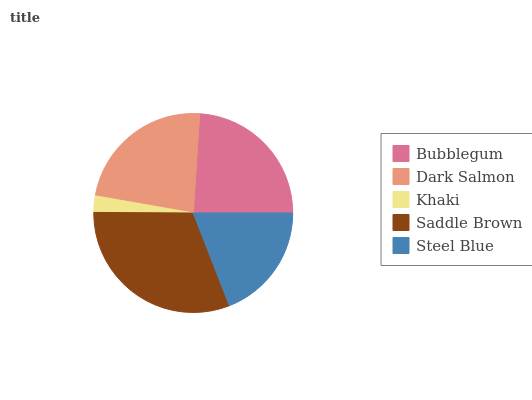Is Khaki the minimum?
Answer yes or no. Yes. Is Saddle Brown the maximum?
Answer yes or no. Yes. Is Dark Salmon the minimum?
Answer yes or no. No. Is Dark Salmon the maximum?
Answer yes or no. No. Is Bubblegum greater than Dark Salmon?
Answer yes or no. Yes. Is Dark Salmon less than Bubblegum?
Answer yes or no. Yes. Is Dark Salmon greater than Bubblegum?
Answer yes or no. No. Is Bubblegum less than Dark Salmon?
Answer yes or no. No. Is Dark Salmon the high median?
Answer yes or no. Yes. Is Dark Salmon the low median?
Answer yes or no. Yes. Is Steel Blue the high median?
Answer yes or no. No. Is Steel Blue the low median?
Answer yes or no. No. 